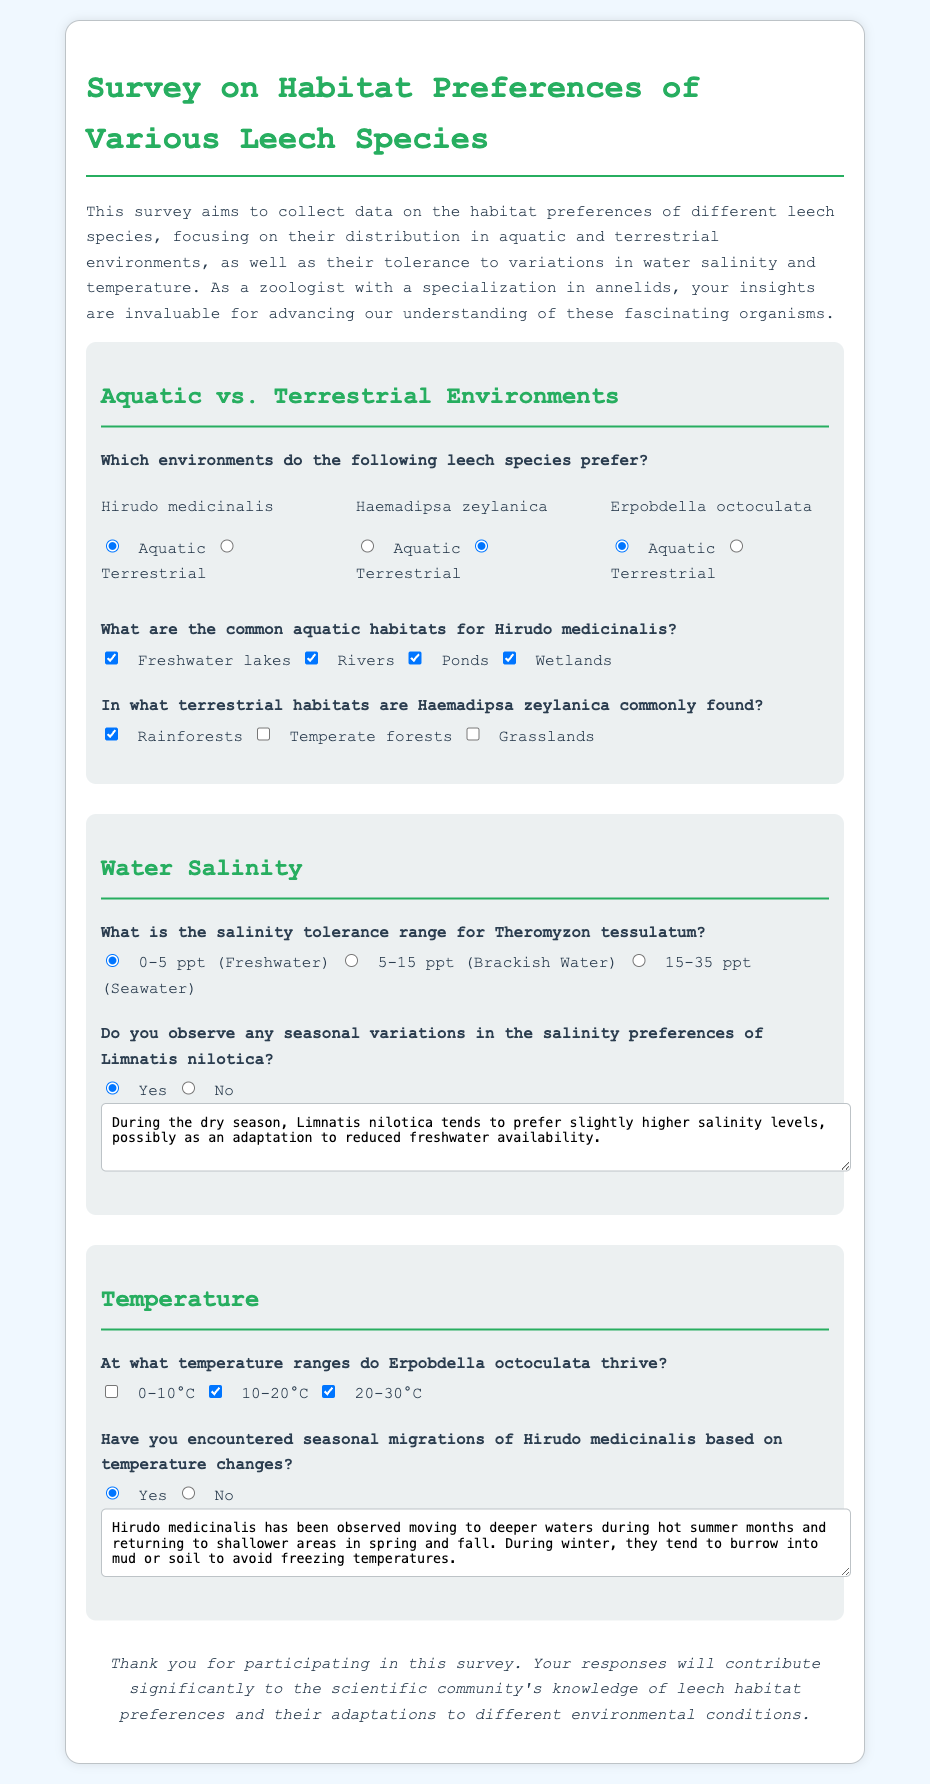What is the preferred habitat of Hirudo medicinalis? Hirudo medicinalis prefers aquatic environments as per the survey results.
Answer: Aquatic In what terrestrial habitats is Haemadipsa zeylanica frequently found? The survey indicates that Haemadipsa zeylanica is commonly found in rainforests, temperate forests, and grasslands.
Answer: Rainforests, Temperate forests, Grasslands What is the salinity tolerance range for Theromyzon tessulatum? The survey specifies that Theromyzon tessulatum has a salinity tolerance range of 0-5 ppt (Freshwater).
Answer: 0-5 ppt (Freshwater) Does Limnatis nilotica exhibit any seasonal variations in salinity preferences? According to the survey, Limnatis nilotica does exhibit seasonal variations based on the responses provided.
Answer: Yes What temperature range do Erpobdella octoculata thrive in? The survey highlights that Erpobdella octoculata thrives between 10-30°C.
Answer: 10-30°C 